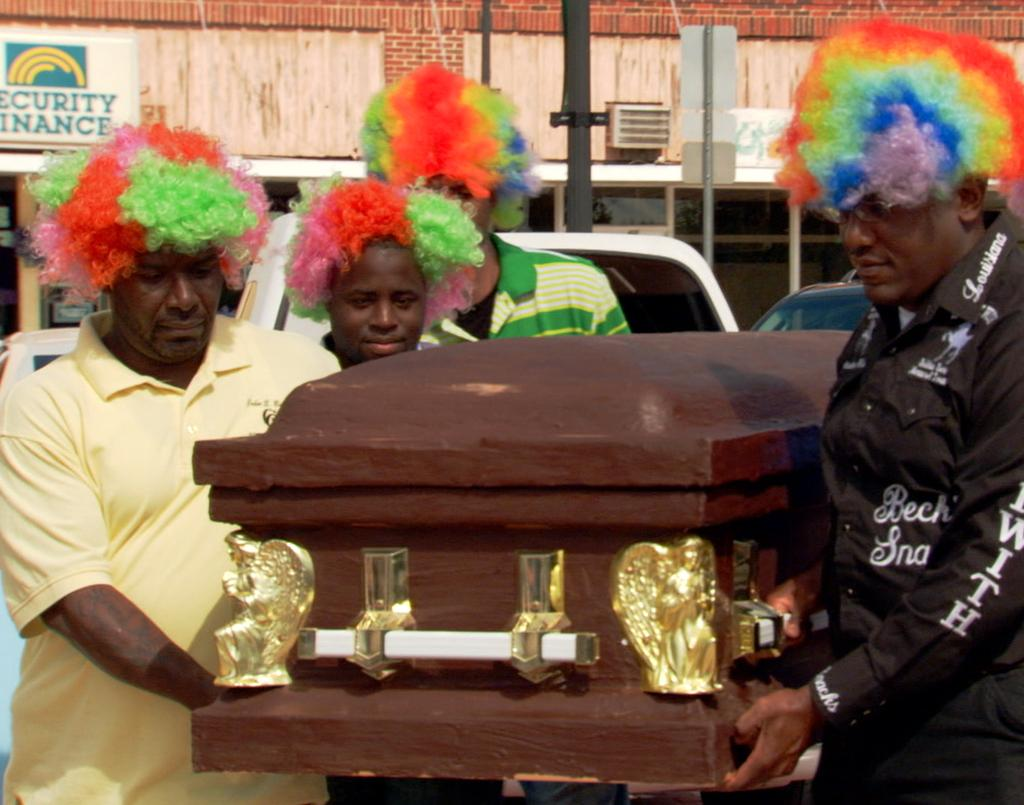What is happening in the image involving the group of people? The people in the image are standing and holding an object. Can you describe the object they are holding? The provided facts do not specify the object they are holding. What can be seen in the background of the image? There is a pole and a building in the background of the image. What type of fiction is being read by the people in the image? There is no indication in the image that the people are reading fiction or any other type of literature. 